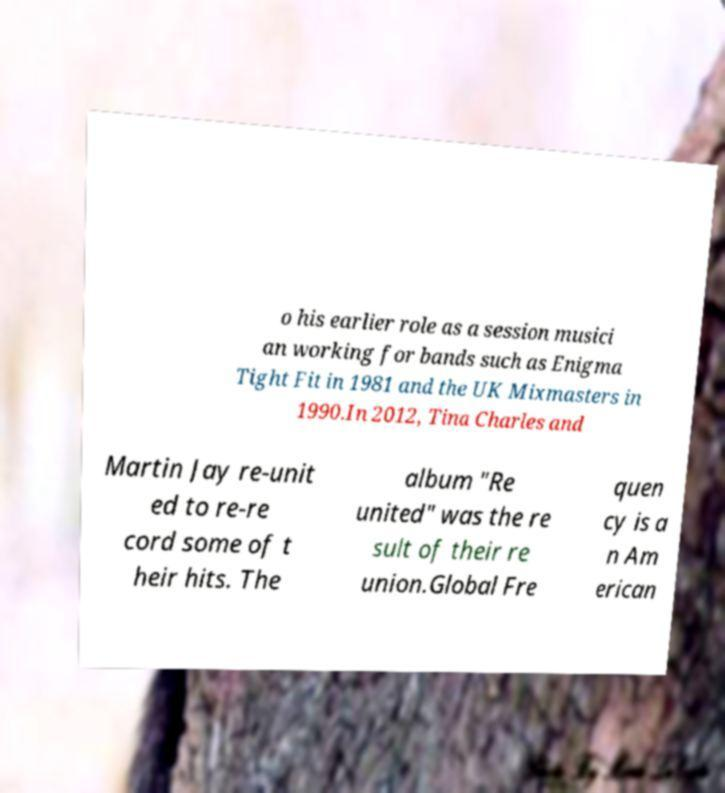Please identify and transcribe the text found in this image. o his earlier role as a session musici an working for bands such as Enigma Tight Fit in 1981 and the UK Mixmasters in 1990.In 2012, Tina Charles and Martin Jay re-unit ed to re-re cord some of t heir hits. The album "Re united" was the re sult of their re union.Global Fre quen cy is a n Am erican 